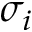<formula> <loc_0><loc_0><loc_500><loc_500>\sigma _ { i }</formula> 